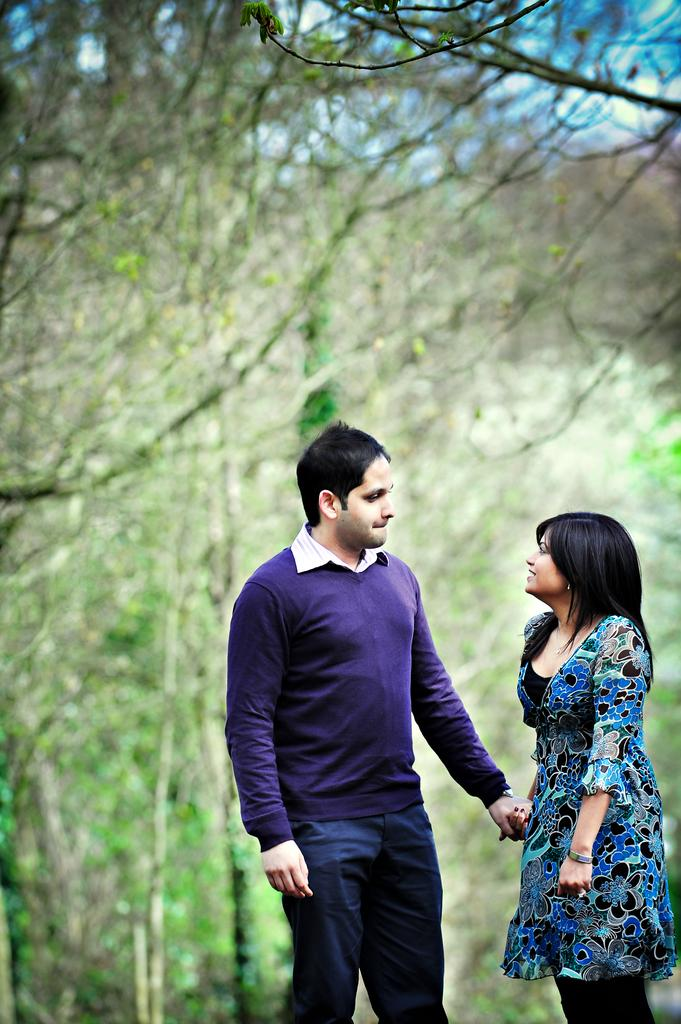How many people are in the image? There are two persons in the image. What are the two persons doing in the image? The two persons are standing and holding hands. What can be seen in the background of the image? There are trees in the background of the image. What type of baby is visible in the image? There is no baby present in the image. What verse can be heard being recited in the image? There is no verse being recited in the image; it is a visual representation of two persons standing and holding hands. 